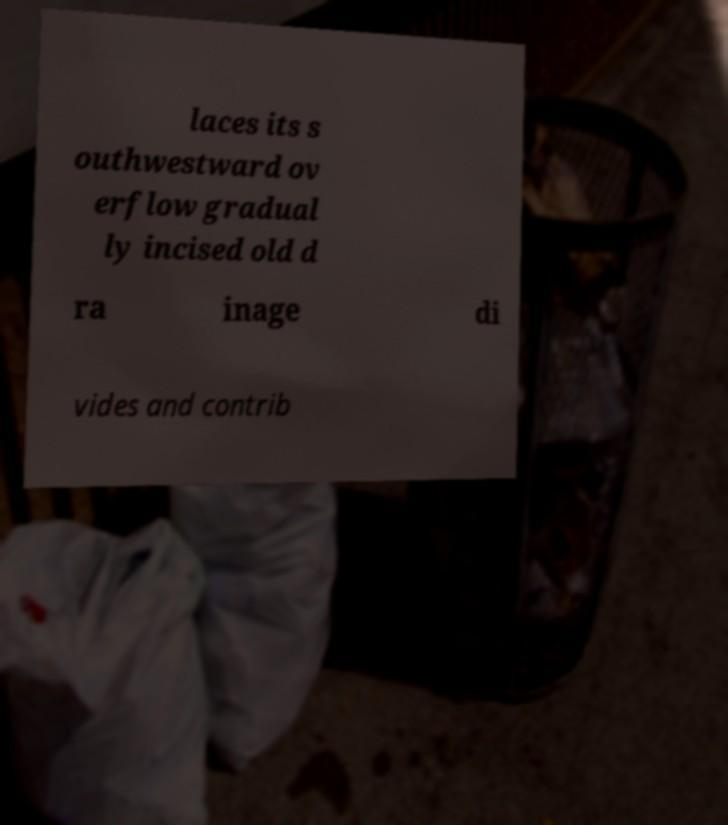Please identify and transcribe the text found in this image. laces its s outhwestward ov erflow gradual ly incised old d ra inage di vides and contrib 